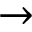<formula> <loc_0><loc_0><loc_500><loc_500>\rightarrow</formula> 